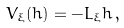<formula> <loc_0><loc_0><loc_500><loc_500>V _ { \xi } ( h ) = - L _ { \xi } h \, ,</formula> 